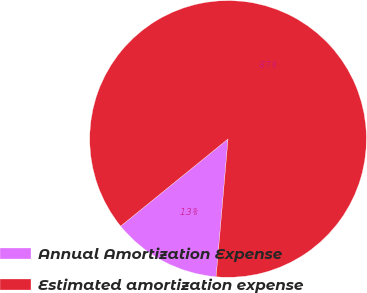Convert chart. <chart><loc_0><loc_0><loc_500><loc_500><pie_chart><fcel>Annual Amortization Expense<fcel>Estimated amortization expense<nl><fcel>12.77%<fcel>87.23%<nl></chart> 